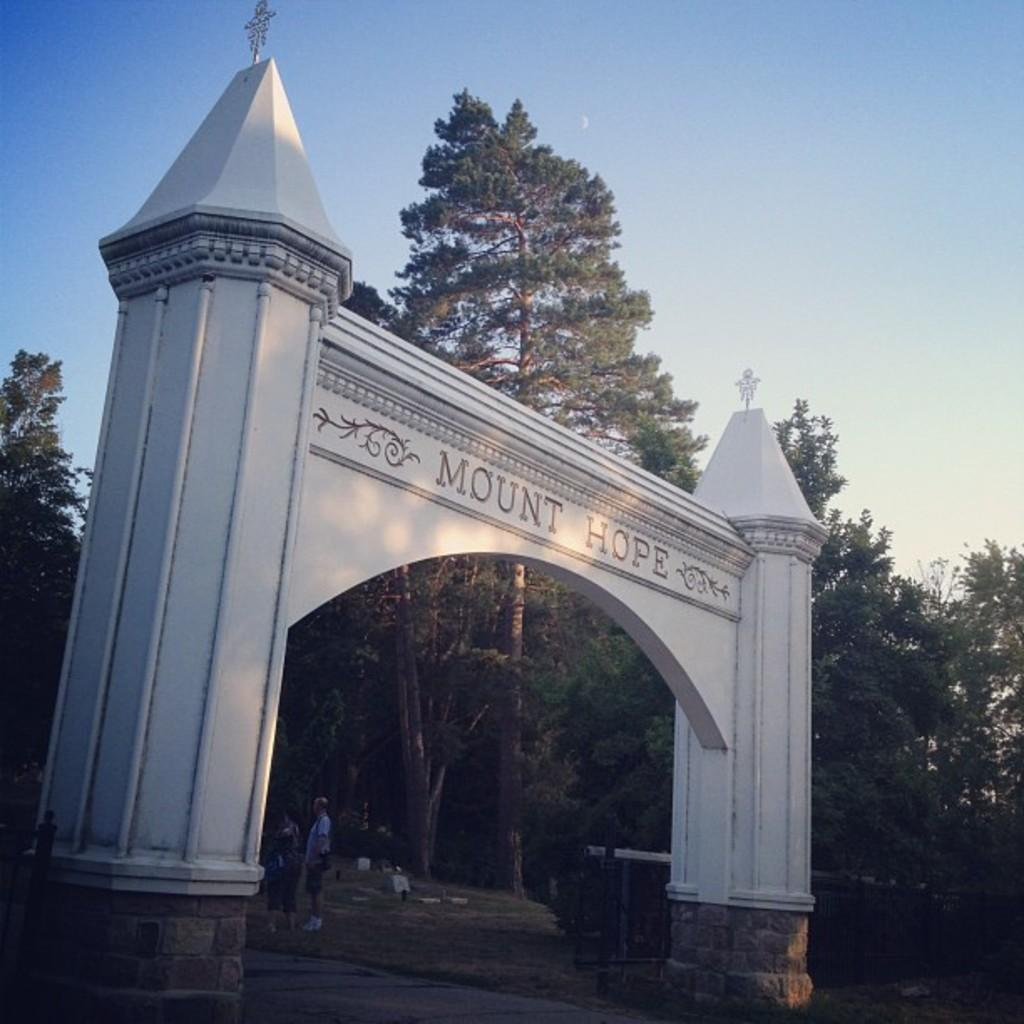What is the name of the arch in the image? The name of the arch in the image is not mentioned in the provided facts. What are the persons in the image doing? The provided facts do not specify what the persons in the image are doing. What can be seen in the background of the image? In the background of the image, there is a road, trees, and the sky visible. What is the primary architectural feature in the image? The primary architectural feature in the image is the arch with a name on it. What type of lock can be seen on the bead in the image? There is no lock or bead present in the image; it features an arch with a name on it, persons, a road, trees, and the sky. 